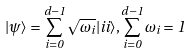Convert formula to latex. <formula><loc_0><loc_0><loc_500><loc_500>| \psi \rangle = \sum ^ { d - 1 } _ { i = 0 } \sqrt { \omega _ { i } } | i i \rangle , \sum ^ { d - 1 } _ { i = 0 } \omega _ { i } = 1</formula> 